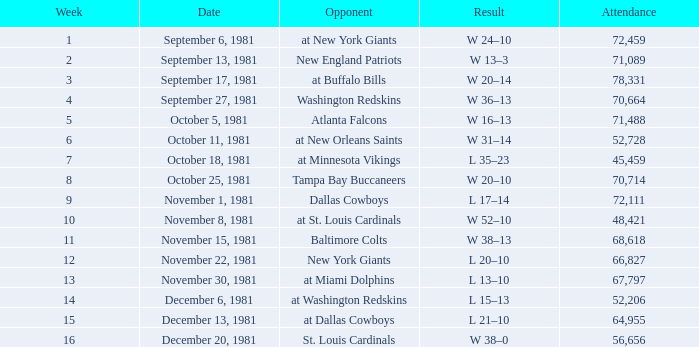What is the average Attendance, when the Date is September 17, 1981? 78331.0. 